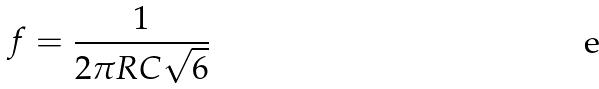Convert formula to latex. <formula><loc_0><loc_0><loc_500><loc_500>f = \frac { 1 } { 2 \pi R C \sqrt { 6 } }</formula> 